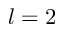<formula> <loc_0><loc_0><loc_500><loc_500>l = 2</formula> 